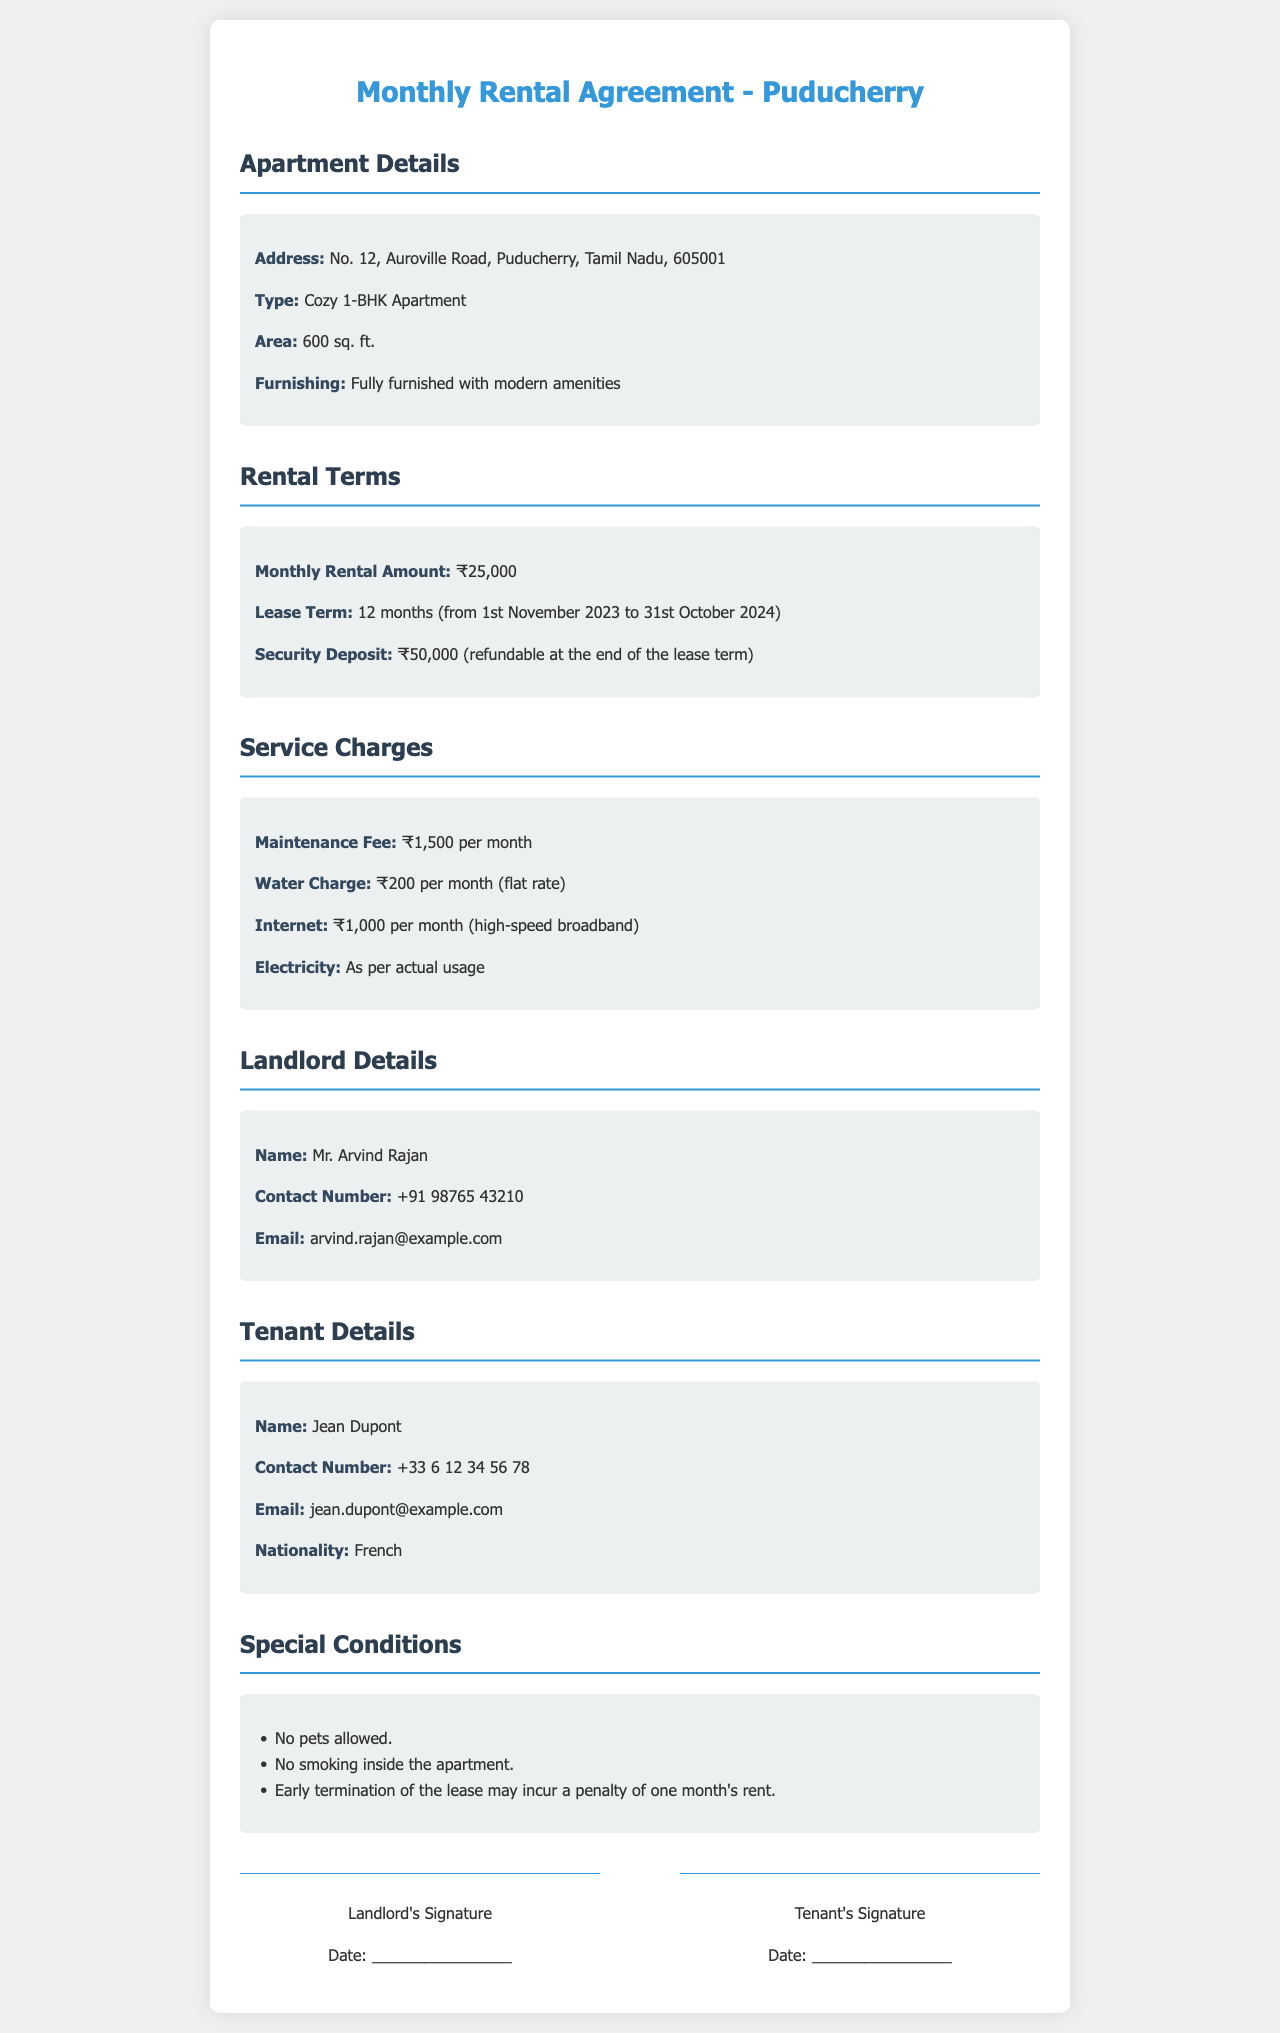What is the monthly rental amount? The monthly rental amount is specified in the Rental Terms section of the document, which states ₹25,000.
Answer: ₹25,000 What is the lease term duration? The lease term duration can be found in the Rental Terms section, which mentions 12 months from 1st November 2023 to 31st October 2024.
Answer: 12 months What is the address of the apartment? The address can be seen in the Apartment Details section, which lists No. 12, Auroville Road, Puducherry, Tamil Nadu, 605001.
Answer: No. 12, Auroville Road, Puducherry, Tamil Nadu, 605001 Who is the landlord? The name of the landlord is provided in the Landlord Details section, which names Mr. Arvind Rajan.
Answer: Mr. Arvind Rajan What is the security deposit amount? The security deposit amount is included in the Rental Terms section, which indicates ₹50,000, refundable at the end of the lease term.
Answer: ₹50,000 What is included in the service charges? The service charges section lists several charges, which include a maintenance fee, water charge, internet, and electricity based on usage.
Answer: Maintenance fee, water charge, internet, electricity Are pets allowed in the apartment? This information can be found in the Special Conditions section, which states that pets are not allowed.
Answer: No What is the maintenance fee per month? The maintenance fee is mentioned in the Service Charges section, stating that it is ₹1,500 per month.
Answer: ₹1,500 per month What is the tenant's nationality? The tenant's nationality is detailed in the Tenant Details section, which states French.
Answer: French 